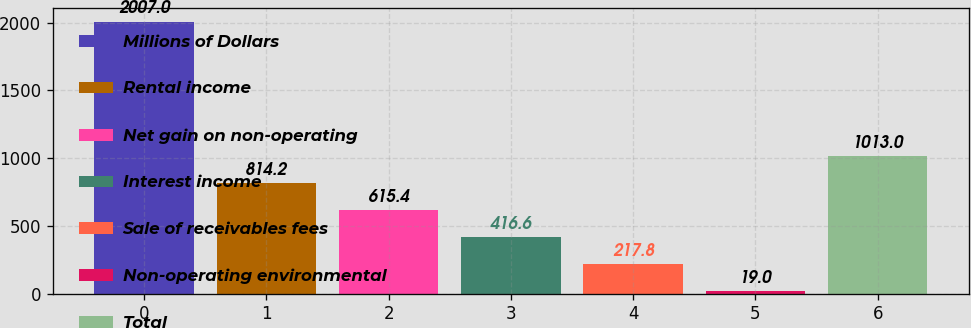Convert chart. <chart><loc_0><loc_0><loc_500><loc_500><bar_chart><fcel>Millions of Dollars<fcel>Rental income<fcel>Net gain on non-operating<fcel>Interest income<fcel>Sale of receivables fees<fcel>Non-operating environmental<fcel>Total<nl><fcel>2007<fcel>814.2<fcel>615.4<fcel>416.6<fcel>217.8<fcel>19<fcel>1013<nl></chart> 